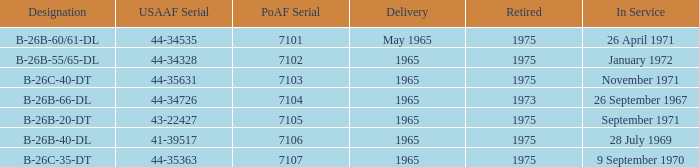What is the earliest year retired delivered in 1965 with an in service in November 1971 for the PoAF Serial less than 7103? None. 